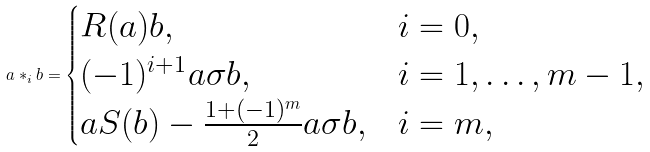Convert formula to latex. <formula><loc_0><loc_0><loc_500><loc_500>a \ast _ { i } b = \begin{cases} R ( a ) b , & i = 0 , \\ ( - 1 ) ^ { i + 1 } a \sigma b , & i = 1 , \dots , m - 1 , \\ a S ( b ) - \frac { 1 + ( - 1 ) ^ { m } } 2 a \sigma b , & i = m , \end{cases}</formula> 